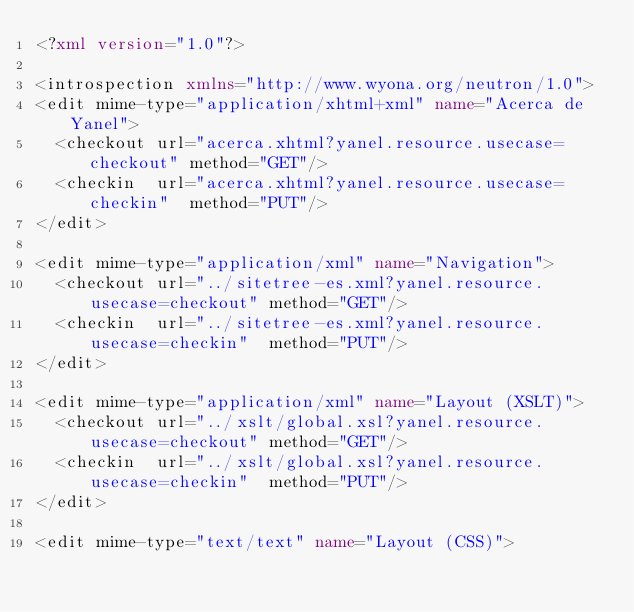<code> <loc_0><loc_0><loc_500><loc_500><_XML_><?xml version="1.0"?>

<introspection xmlns="http://www.wyona.org/neutron/1.0">
<edit mime-type="application/xhtml+xml" name="Acerca de Yanel">
  <checkout url="acerca.xhtml?yanel.resource.usecase=checkout" method="GET"/>
  <checkin  url="acerca.xhtml?yanel.resource.usecase=checkin"  method="PUT"/>
</edit>

<edit mime-type="application/xml" name="Navigation">
  <checkout url="../sitetree-es.xml?yanel.resource.usecase=checkout" method="GET"/>
  <checkin  url="../sitetree-es.xml?yanel.resource.usecase=checkin"  method="PUT"/>
</edit>

<edit mime-type="application/xml" name="Layout (XSLT)">
  <checkout url="../xslt/global.xsl?yanel.resource.usecase=checkout" method="GET"/>
  <checkin  url="../xslt/global.xsl?yanel.resource.usecase=checkin"  method="PUT"/>
</edit>

<edit mime-type="text/text" name="Layout (CSS)"></code> 